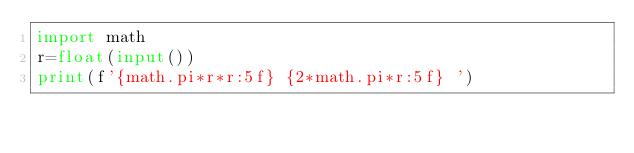<code> <loc_0><loc_0><loc_500><loc_500><_Python_>import math
r=float(input())
print(f'{math.pi*r*r:5f} {2*math.pi*r:5f} ')
</code> 